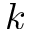<formula> <loc_0><loc_0><loc_500><loc_500>\ v { k }</formula> 